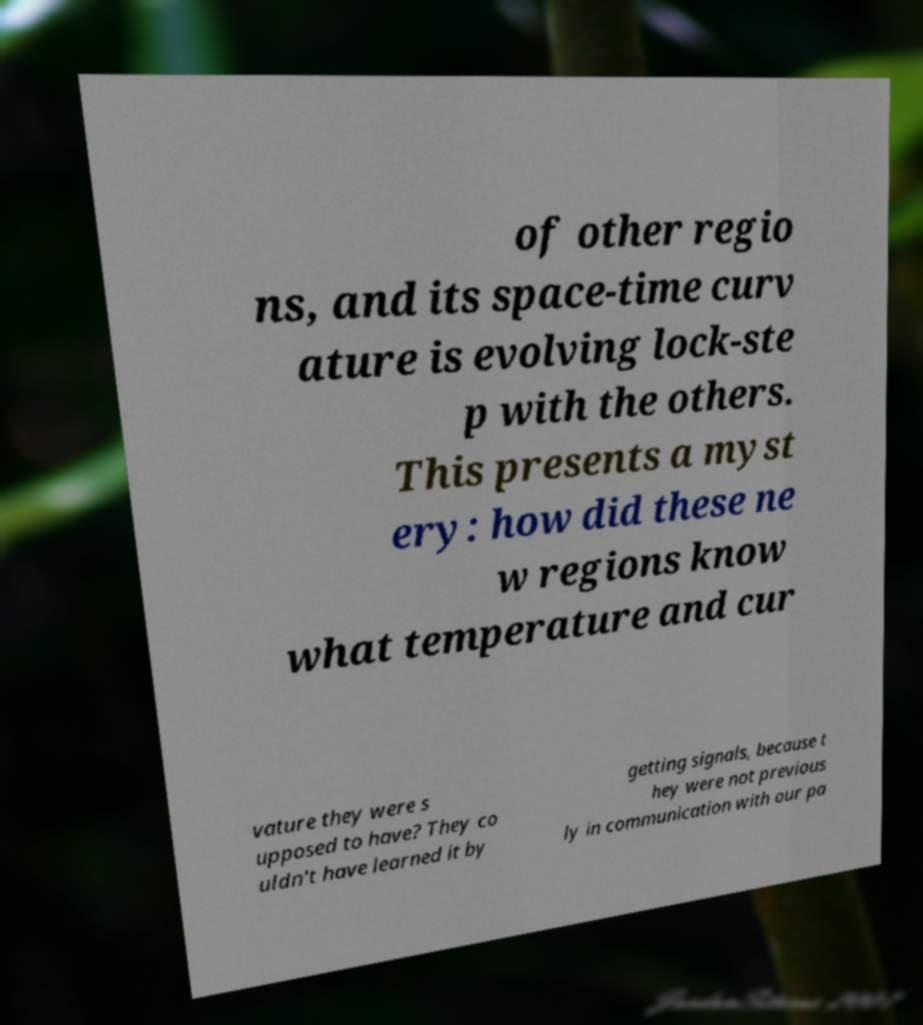What messages or text are displayed in this image? I need them in a readable, typed format. of other regio ns, and its space-time curv ature is evolving lock-ste p with the others. This presents a myst ery: how did these ne w regions know what temperature and cur vature they were s upposed to have? They co uldn't have learned it by getting signals, because t hey were not previous ly in communication with our pa 